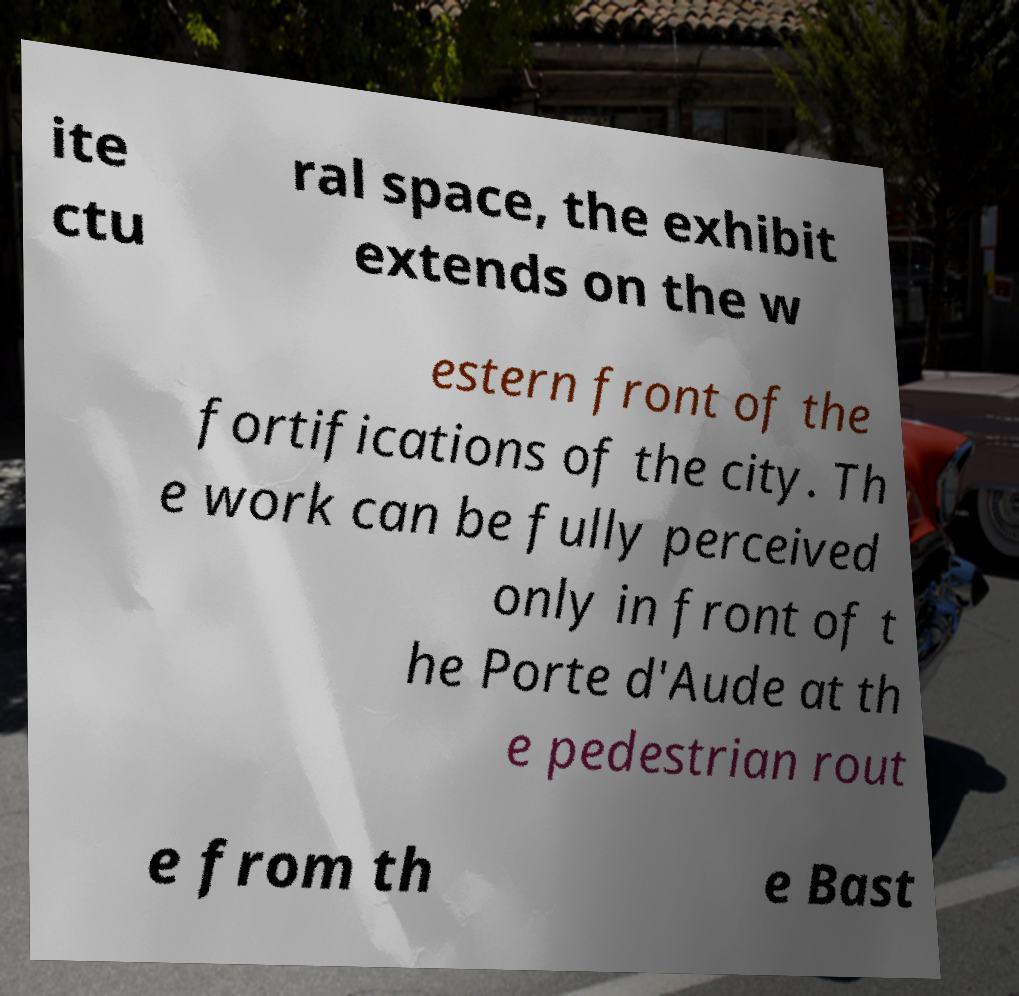For documentation purposes, I need the text within this image transcribed. Could you provide that? ite ctu ral space, the exhibit extends on the w estern front of the fortifications of the city. Th e work can be fully perceived only in front of t he Porte d'Aude at th e pedestrian rout e from th e Bast 